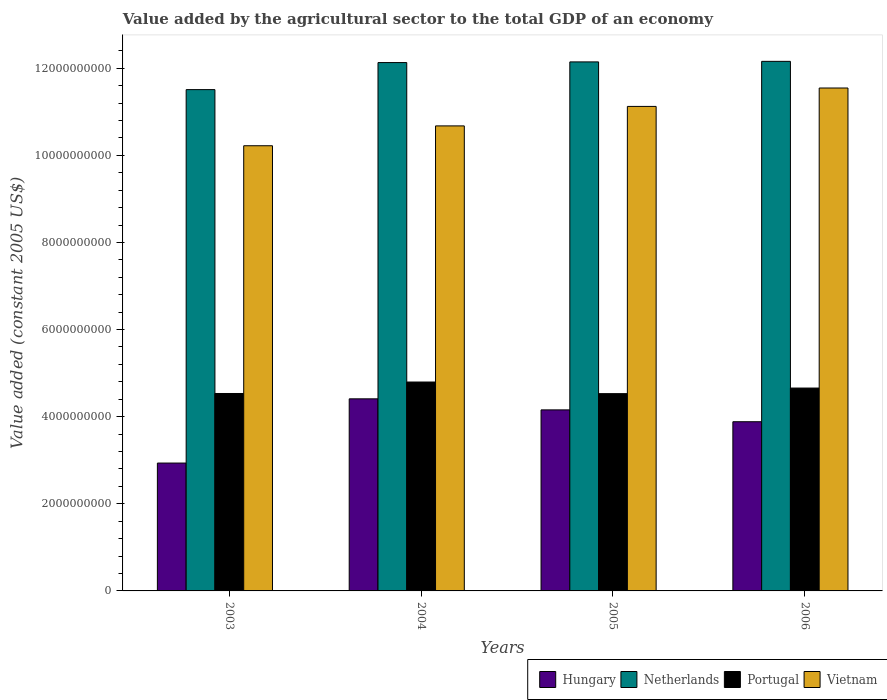Are the number of bars per tick equal to the number of legend labels?
Give a very brief answer. Yes. How many bars are there on the 3rd tick from the left?
Your response must be concise. 4. In how many cases, is the number of bars for a given year not equal to the number of legend labels?
Offer a very short reply. 0. What is the value added by the agricultural sector in Hungary in 2005?
Offer a terse response. 4.16e+09. Across all years, what is the maximum value added by the agricultural sector in Netherlands?
Offer a terse response. 1.22e+1. Across all years, what is the minimum value added by the agricultural sector in Hungary?
Your response must be concise. 2.94e+09. In which year was the value added by the agricultural sector in Hungary minimum?
Provide a short and direct response. 2003. What is the total value added by the agricultural sector in Portugal in the graph?
Keep it short and to the point. 1.85e+1. What is the difference between the value added by the agricultural sector in Vietnam in 2003 and that in 2006?
Give a very brief answer. -1.33e+09. What is the difference between the value added by the agricultural sector in Netherlands in 2003 and the value added by the agricultural sector in Hungary in 2006?
Provide a short and direct response. 7.62e+09. What is the average value added by the agricultural sector in Hungary per year?
Make the answer very short. 3.85e+09. In the year 2003, what is the difference between the value added by the agricultural sector in Portugal and value added by the agricultural sector in Netherlands?
Your response must be concise. -6.98e+09. What is the ratio of the value added by the agricultural sector in Portugal in 2004 to that in 2005?
Provide a succinct answer. 1.06. Is the value added by the agricultural sector in Vietnam in 2003 less than that in 2004?
Offer a very short reply. Yes. What is the difference between the highest and the second highest value added by the agricultural sector in Hungary?
Make the answer very short. 2.54e+08. What is the difference between the highest and the lowest value added by the agricultural sector in Vietnam?
Provide a short and direct response. 1.33e+09. Is the sum of the value added by the agricultural sector in Vietnam in 2003 and 2006 greater than the maximum value added by the agricultural sector in Hungary across all years?
Your answer should be compact. Yes. What does the 1st bar from the right in 2003 represents?
Your answer should be very brief. Vietnam. Is it the case that in every year, the sum of the value added by the agricultural sector in Netherlands and value added by the agricultural sector in Vietnam is greater than the value added by the agricultural sector in Portugal?
Ensure brevity in your answer.  Yes. How many bars are there?
Keep it short and to the point. 16. Are all the bars in the graph horizontal?
Offer a very short reply. No. What is the difference between two consecutive major ticks on the Y-axis?
Your response must be concise. 2.00e+09. Does the graph contain any zero values?
Make the answer very short. No. Where does the legend appear in the graph?
Your response must be concise. Bottom right. How are the legend labels stacked?
Your answer should be compact. Horizontal. What is the title of the graph?
Ensure brevity in your answer.  Value added by the agricultural sector to the total GDP of an economy. Does "Burkina Faso" appear as one of the legend labels in the graph?
Your response must be concise. No. What is the label or title of the Y-axis?
Provide a succinct answer. Value added (constant 2005 US$). What is the Value added (constant 2005 US$) of Hungary in 2003?
Offer a very short reply. 2.94e+09. What is the Value added (constant 2005 US$) in Netherlands in 2003?
Your response must be concise. 1.15e+1. What is the Value added (constant 2005 US$) of Portugal in 2003?
Offer a terse response. 4.53e+09. What is the Value added (constant 2005 US$) of Vietnam in 2003?
Provide a short and direct response. 1.02e+1. What is the Value added (constant 2005 US$) of Hungary in 2004?
Keep it short and to the point. 4.41e+09. What is the Value added (constant 2005 US$) in Netherlands in 2004?
Ensure brevity in your answer.  1.21e+1. What is the Value added (constant 2005 US$) of Portugal in 2004?
Your response must be concise. 4.80e+09. What is the Value added (constant 2005 US$) in Vietnam in 2004?
Make the answer very short. 1.07e+1. What is the Value added (constant 2005 US$) in Hungary in 2005?
Make the answer very short. 4.16e+09. What is the Value added (constant 2005 US$) in Netherlands in 2005?
Offer a very short reply. 1.21e+1. What is the Value added (constant 2005 US$) in Portugal in 2005?
Offer a very short reply. 4.53e+09. What is the Value added (constant 2005 US$) in Vietnam in 2005?
Your answer should be very brief. 1.11e+1. What is the Value added (constant 2005 US$) in Hungary in 2006?
Your response must be concise. 3.88e+09. What is the Value added (constant 2005 US$) in Netherlands in 2006?
Offer a terse response. 1.22e+1. What is the Value added (constant 2005 US$) in Portugal in 2006?
Make the answer very short. 4.66e+09. What is the Value added (constant 2005 US$) of Vietnam in 2006?
Give a very brief answer. 1.15e+1. Across all years, what is the maximum Value added (constant 2005 US$) in Hungary?
Ensure brevity in your answer.  4.41e+09. Across all years, what is the maximum Value added (constant 2005 US$) in Netherlands?
Your answer should be compact. 1.22e+1. Across all years, what is the maximum Value added (constant 2005 US$) in Portugal?
Your answer should be compact. 4.80e+09. Across all years, what is the maximum Value added (constant 2005 US$) in Vietnam?
Offer a very short reply. 1.15e+1. Across all years, what is the minimum Value added (constant 2005 US$) in Hungary?
Offer a very short reply. 2.94e+09. Across all years, what is the minimum Value added (constant 2005 US$) of Netherlands?
Your answer should be very brief. 1.15e+1. Across all years, what is the minimum Value added (constant 2005 US$) of Portugal?
Provide a succinct answer. 4.53e+09. Across all years, what is the minimum Value added (constant 2005 US$) of Vietnam?
Provide a short and direct response. 1.02e+1. What is the total Value added (constant 2005 US$) of Hungary in the graph?
Provide a short and direct response. 1.54e+1. What is the total Value added (constant 2005 US$) of Netherlands in the graph?
Ensure brevity in your answer.  4.79e+1. What is the total Value added (constant 2005 US$) in Portugal in the graph?
Keep it short and to the point. 1.85e+1. What is the total Value added (constant 2005 US$) in Vietnam in the graph?
Your answer should be compact. 4.36e+1. What is the difference between the Value added (constant 2005 US$) of Hungary in 2003 and that in 2004?
Your answer should be very brief. -1.47e+09. What is the difference between the Value added (constant 2005 US$) in Netherlands in 2003 and that in 2004?
Provide a short and direct response. -6.21e+08. What is the difference between the Value added (constant 2005 US$) of Portugal in 2003 and that in 2004?
Make the answer very short. -2.63e+08. What is the difference between the Value added (constant 2005 US$) of Vietnam in 2003 and that in 2004?
Provide a short and direct response. -4.56e+08. What is the difference between the Value added (constant 2005 US$) in Hungary in 2003 and that in 2005?
Your answer should be very brief. -1.22e+09. What is the difference between the Value added (constant 2005 US$) in Netherlands in 2003 and that in 2005?
Keep it short and to the point. -6.36e+08. What is the difference between the Value added (constant 2005 US$) in Portugal in 2003 and that in 2005?
Provide a succinct answer. 3.53e+06. What is the difference between the Value added (constant 2005 US$) of Vietnam in 2003 and that in 2005?
Your response must be concise. -9.03e+08. What is the difference between the Value added (constant 2005 US$) of Hungary in 2003 and that in 2006?
Your answer should be very brief. -9.49e+08. What is the difference between the Value added (constant 2005 US$) of Netherlands in 2003 and that in 2006?
Offer a terse response. -6.49e+08. What is the difference between the Value added (constant 2005 US$) in Portugal in 2003 and that in 2006?
Provide a short and direct response. -1.25e+08. What is the difference between the Value added (constant 2005 US$) of Vietnam in 2003 and that in 2006?
Offer a very short reply. -1.33e+09. What is the difference between the Value added (constant 2005 US$) of Hungary in 2004 and that in 2005?
Your response must be concise. 2.54e+08. What is the difference between the Value added (constant 2005 US$) of Netherlands in 2004 and that in 2005?
Your response must be concise. -1.54e+07. What is the difference between the Value added (constant 2005 US$) of Portugal in 2004 and that in 2005?
Offer a very short reply. 2.67e+08. What is the difference between the Value added (constant 2005 US$) in Vietnam in 2004 and that in 2005?
Offer a terse response. -4.47e+08. What is the difference between the Value added (constant 2005 US$) of Hungary in 2004 and that in 2006?
Your response must be concise. 5.26e+08. What is the difference between the Value added (constant 2005 US$) in Netherlands in 2004 and that in 2006?
Keep it short and to the point. -2.79e+07. What is the difference between the Value added (constant 2005 US$) in Portugal in 2004 and that in 2006?
Make the answer very short. 1.38e+08. What is the difference between the Value added (constant 2005 US$) of Vietnam in 2004 and that in 2006?
Offer a terse response. -8.70e+08. What is the difference between the Value added (constant 2005 US$) of Hungary in 2005 and that in 2006?
Ensure brevity in your answer.  2.72e+08. What is the difference between the Value added (constant 2005 US$) of Netherlands in 2005 and that in 2006?
Offer a very short reply. -1.24e+07. What is the difference between the Value added (constant 2005 US$) of Portugal in 2005 and that in 2006?
Ensure brevity in your answer.  -1.28e+08. What is the difference between the Value added (constant 2005 US$) in Vietnam in 2005 and that in 2006?
Give a very brief answer. -4.22e+08. What is the difference between the Value added (constant 2005 US$) in Hungary in 2003 and the Value added (constant 2005 US$) in Netherlands in 2004?
Make the answer very short. -9.19e+09. What is the difference between the Value added (constant 2005 US$) of Hungary in 2003 and the Value added (constant 2005 US$) of Portugal in 2004?
Your answer should be compact. -1.86e+09. What is the difference between the Value added (constant 2005 US$) of Hungary in 2003 and the Value added (constant 2005 US$) of Vietnam in 2004?
Your response must be concise. -7.74e+09. What is the difference between the Value added (constant 2005 US$) of Netherlands in 2003 and the Value added (constant 2005 US$) of Portugal in 2004?
Offer a terse response. 6.71e+09. What is the difference between the Value added (constant 2005 US$) in Netherlands in 2003 and the Value added (constant 2005 US$) in Vietnam in 2004?
Keep it short and to the point. 8.33e+08. What is the difference between the Value added (constant 2005 US$) in Portugal in 2003 and the Value added (constant 2005 US$) in Vietnam in 2004?
Offer a very short reply. -6.14e+09. What is the difference between the Value added (constant 2005 US$) in Hungary in 2003 and the Value added (constant 2005 US$) in Netherlands in 2005?
Offer a very short reply. -9.21e+09. What is the difference between the Value added (constant 2005 US$) of Hungary in 2003 and the Value added (constant 2005 US$) of Portugal in 2005?
Offer a very short reply. -1.59e+09. What is the difference between the Value added (constant 2005 US$) in Hungary in 2003 and the Value added (constant 2005 US$) in Vietnam in 2005?
Your answer should be compact. -8.19e+09. What is the difference between the Value added (constant 2005 US$) of Netherlands in 2003 and the Value added (constant 2005 US$) of Portugal in 2005?
Ensure brevity in your answer.  6.98e+09. What is the difference between the Value added (constant 2005 US$) of Netherlands in 2003 and the Value added (constant 2005 US$) of Vietnam in 2005?
Offer a very short reply. 3.86e+08. What is the difference between the Value added (constant 2005 US$) of Portugal in 2003 and the Value added (constant 2005 US$) of Vietnam in 2005?
Ensure brevity in your answer.  -6.59e+09. What is the difference between the Value added (constant 2005 US$) in Hungary in 2003 and the Value added (constant 2005 US$) in Netherlands in 2006?
Your answer should be compact. -9.22e+09. What is the difference between the Value added (constant 2005 US$) of Hungary in 2003 and the Value added (constant 2005 US$) of Portugal in 2006?
Offer a very short reply. -1.72e+09. What is the difference between the Value added (constant 2005 US$) in Hungary in 2003 and the Value added (constant 2005 US$) in Vietnam in 2006?
Your response must be concise. -8.61e+09. What is the difference between the Value added (constant 2005 US$) in Netherlands in 2003 and the Value added (constant 2005 US$) in Portugal in 2006?
Provide a succinct answer. 6.85e+09. What is the difference between the Value added (constant 2005 US$) in Netherlands in 2003 and the Value added (constant 2005 US$) in Vietnam in 2006?
Ensure brevity in your answer.  -3.67e+07. What is the difference between the Value added (constant 2005 US$) in Portugal in 2003 and the Value added (constant 2005 US$) in Vietnam in 2006?
Ensure brevity in your answer.  -7.01e+09. What is the difference between the Value added (constant 2005 US$) in Hungary in 2004 and the Value added (constant 2005 US$) in Netherlands in 2005?
Give a very brief answer. -7.74e+09. What is the difference between the Value added (constant 2005 US$) of Hungary in 2004 and the Value added (constant 2005 US$) of Portugal in 2005?
Keep it short and to the point. -1.19e+08. What is the difference between the Value added (constant 2005 US$) in Hungary in 2004 and the Value added (constant 2005 US$) in Vietnam in 2005?
Your answer should be very brief. -6.71e+09. What is the difference between the Value added (constant 2005 US$) of Netherlands in 2004 and the Value added (constant 2005 US$) of Portugal in 2005?
Provide a succinct answer. 7.60e+09. What is the difference between the Value added (constant 2005 US$) of Netherlands in 2004 and the Value added (constant 2005 US$) of Vietnam in 2005?
Your response must be concise. 1.01e+09. What is the difference between the Value added (constant 2005 US$) of Portugal in 2004 and the Value added (constant 2005 US$) of Vietnam in 2005?
Offer a very short reply. -6.33e+09. What is the difference between the Value added (constant 2005 US$) of Hungary in 2004 and the Value added (constant 2005 US$) of Netherlands in 2006?
Provide a succinct answer. -7.75e+09. What is the difference between the Value added (constant 2005 US$) of Hungary in 2004 and the Value added (constant 2005 US$) of Portugal in 2006?
Your response must be concise. -2.47e+08. What is the difference between the Value added (constant 2005 US$) of Hungary in 2004 and the Value added (constant 2005 US$) of Vietnam in 2006?
Make the answer very short. -7.14e+09. What is the difference between the Value added (constant 2005 US$) in Netherlands in 2004 and the Value added (constant 2005 US$) in Portugal in 2006?
Your response must be concise. 7.47e+09. What is the difference between the Value added (constant 2005 US$) in Netherlands in 2004 and the Value added (constant 2005 US$) in Vietnam in 2006?
Ensure brevity in your answer.  5.84e+08. What is the difference between the Value added (constant 2005 US$) of Portugal in 2004 and the Value added (constant 2005 US$) of Vietnam in 2006?
Ensure brevity in your answer.  -6.75e+09. What is the difference between the Value added (constant 2005 US$) in Hungary in 2005 and the Value added (constant 2005 US$) in Netherlands in 2006?
Provide a succinct answer. -8.00e+09. What is the difference between the Value added (constant 2005 US$) of Hungary in 2005 and the Value added (constant 2005 US$) of Portugal in 2006?
Give a very brief answer. -5.01e+08. What is the difference between the Value added (constant 2005 US$) in Hungary in 2005 and the Value added (constant 2005 US$) in Vietnam in 2006?
Your response must be concise. -7.39e+09. What is the difference between the Value added (constant 2005 US$) of Netherlands in 2005 and the Value added (constant 2005 US$) of Portugal in 2006?
Provide a short and direct response. 7.49e+09. What is the difference between the Value added (constant 2005 US$) in Netherlands in 2005 and the Value added (constant 2005 US$) in Vietnam in 2006?
Keep it short and to the point. 6.00e+08. What is the difference between the Value added (constant 2005 US$) in Portugal in 2005 and the Value added (constant 2005 US$) in Vietnam in 2006?
Keep it short and to the point. -7.02e+09. What is the average Value added (constant 2005 US$) of Hungary per year?
Your answer should be very brief. 3.85e+09. What is the average Value added (constant 2005 US$) of Netherlands per year?
Offer a very short reply. 1.20e+1. What is the average Value added (constant 2005 US$) of Portugal per year?
Keep it short and to the point. 4.63e+09. What is the average Value added (constant 2005 US$) of Vietnam per year?
Provide a succinct answer. 1.09e+1. In the year 2003, what is the difference between the Value added (constant 2005 US$) of Hungary and Value added (constant 2005 US$) of Netherlands?
Make the answer very short. -8.57e+09. In the year 2003, what is the difference between the Value added (constant 2005 US$) in Hungary and Value added (constant 2005 US$) in Portugal?
Provide a succinct answer. -1.60e+09. In the year 2003, what is the difference between the Value added (constant 2005 US$) in Hungary and Value added (constant 2005 US$) in Vietnam?
Offer a terse response. -7.28e+09. In the year 2003, what is the difference between the Value added (constant 2005 US$) of Netherlands and Value added (constant 2005 US$) of Portugal?
Keep it short and to the point. 6.98e+09. In the year 2003, what is the difference between the Value added (constant 2005 US$) in Netherlands and Value added (constant 2005 US$) in Vietnam?
Provide a succinct answer. 1.29e+09. In the year 2003, what is the difference between the Value added (constant 2005 US$) of Portugal and Value added (constant 2005 US$) of Vietnam?
Provide a succinct answer. -5.69e+09. In the year 2004, what is the difference between the Value added (constant 2005 US$) in Hungary and Value added (constant 2005 US$) in Netherlands?
Provide a short and direct response. -7.72e+09. In the year 2004, what is the difference between the Value added (constant 2005 US$) in Hungary and Value added (constant 2005 US$) in Portugal?
Offer a terse response. -3.86e+08. In the year 2004, what is the difference between the Value added (constant 2005 US$) in Hungary and Value added (constant 2005 US$) in Vietnam?
Give a very brief answer. -6.27e+09. In the year 2004, what is the difference between the Value added (constant 2005 US$) in Netherlands and Value added (constant 2005 US$) in Portugal?
Ensure brevity in your answer.  7.33e+09. In the year 2004, what is the difference between the Value added (constant 2005 US$) of Netherlands and Value added (constant 2005 US$) of Vietnam?
Ensure brevity in your answer.  1.45e+09. In the year 2004, what is the difference between the Value added (constant 2005 US$) of Portugal and Value added (constant 2005 US$) of Vietnam?
Keep it short and to the point. -5.88e+09. In the year 2005, what is the difference between the Value added (constant 2005 US$) in Hungary and Value added (constant 2005 US$) in Netherlands?
Make the answer very short. -7.99e+09. In the year 2005, what is the difference between the Value added (constant 2005 US$) in Hungary and Value added (constant 2005 US$) in Portugal?
Your response must be concise. -3.73e+08. In the year 2005, what is the difference between the Value added (constant 2005 US$) of Hungary and Value added (constant 2005 US$) of Vietnam?
Your answer should be compact. -6.97e+09. In the year 2005, what is the difference between the Value added (constant 2005 US$) of Netherlands and Value added (constant 2005 US$) of Portugal?
Your answer should be very brief. 7.62e+09. In the year 2005, what is the difference between the Value added (constant 2005 US$) of Netherlands and Value added (constant 2005 US$) of Vietnam?
Keep it short and to the point. 1.02e+09. In the year 2005, what is the difference between the Value added (constant 2005 US$) of Portugal and Value added (constant 2005 US$) of Vietnam?
Your answer should be very brief. -6.59e+09. In the year 2006, what is the difference between the Value added (constant 2005 US$) of Hungary and Value added (constant 2005 US$) of Netherlands?
Your answer should be compact. -8.27e+09. In the year 2006, what is the difference between the Value added (constant 2005 US$) in Hungary and Value added (constant 2005 US$) in Portugal?
Provide a succinct answer. -7.73e+08. In the year 2006, what is the difference between the Value added (constant 2005 US$) of Hungary and Value added (constant 2005 US$) of Vietnam?
Ensure brevity in your answer.  -7.66e+09. In the year 2006, what is the difference between the Value added (constant 2005 US$) in Netherlands and Value added (constant 2005 US$) in Portugal?
Provide a short and direct response. 7.50e+09. In the year 2006, what is the difference between the Value added (constant 2005 US$) of Netherlands and Value added (constant 2005 US$) of Vietnam?
Offer a very short reply. 6.12e+08. In the year 2006, what is the difference between the Value added (constant 2005 US$) of Portugal and Value added (constant 2005 US$) of Vietnam?
Ensure brevity in your answer.  -6.89e+09. What is the ratio of the Value added (constant 2005 US$) of Hungary in 2003 to that in 2004?
Your answer should be very brief. 0.67. What is the ratio of the Value added (constant 2005 US$) in Netherlands in 2003 to that in 2004?
Ensure brevity in your answer.  0.95. What is the ratio of the Value added (constant 2005 US$) of Portugal in 2003 to that in 2004?
Your answer should be compact. 0.95. What is the ratio of the Value added (constant 2005 US$) in Vietnam in 2003 to that in 2004?
Offer a terse response. 0.96. What is the ratio of the Value added (constant 2005 US$) in Hungary in 2003 to that in 2005?
Your response must be concise. 0.71. What is the ratio of the Value added (constant 2005 US$) in Netherlands in 2003 to that in 2005?
Keep it short and to the point. 0.95. What is the ratio of the Value added (constant 2005 US$) of Portugal in 2003 to that in 2005?
Provide a short and direct response. 1. What is the ratio of the Value added (constant 2005 US$) in Vietnam in 2003 to that in 2005?
Keep it short and to the point. 0.92. What is the ratio of the Value added (constant 2005 US$) of Hungary in 2003 to that in 2006?
Make the answer very short. 0.76. What is the ratio of the Value added (constant 2005 US$) in Netherlands in 2003 to that in 2006?
Offer a very short reply. 0.95. What is the ratio of the Value added (constant 2005 US$) in Portugal in 2003 to that in 2006?
Your response must be concise. 0.97. What is the ratio of the Value added (constant 2005 US$) of Vietnam in 2003 to that in 2006?
Your response must be concise. 0.89. What is the ratio of the Value added (constant 2005 US$) in Hungary in 2004 to that in 2005?
Keep it short and to the point. 1.06. What is the ratio of the Value added (constant 2005 US$) of Netherlands in 2004 to that in 2005?
Make the answer very short. 1. What is the ratio of the Value added (constant 2005 US$) in Portugal in 2004 to that in 2005?
Your response must be concise. 1.06. What is the ratio of the Value added (constant 2005 US$) of Vietnam in 2004 to that in 2005?
Provide a short and direct response. 0.96. What is the ratio of the Value added (constant 2005 US$) of Hungary in 2004 to that in 2006?
Provide a succinct answer. 1.14. What is the ratio of the Value added (constant 2005 US$) of Portugal in 2004 to that in 2006?
Your answer should be compact. 1.03. What is the ratio of the Value added (constant 2005 US$) in Vietnam in 2004 to that in 2006?
Your answer should be very brief. 0.92. What is the ratio of the Value added (constant 2005 US$) in Hungary in 2005 to that in 2006?
Offer a terse response. 1.07. What is the ratio of the Value added (constant 2005 US$) of Portugal in 2005 to that in 2006?
Your answer should be very brief. 0.97. What is the ratio of the Value added (constant 2005 US$) of Vietnam in 2005 to that in 2006?
Your response must be concise. 0.96. What is the difference between the highest and the second highest Value added (constant 2005 US$) of Hungary?
Provide a succinct answer. 2.54e+08. What is the difference between the highest and the second highest Value added (constant 2005 US$) in Netherlands?
Give a very brief answer. 1.24e+07. What is the difference between the highest and the second highest Value added (constant 2005 US$) in Portugal?
Ensure brevity in your answer.  1.38e+08. What is the difference between the highest and the second highest Value added (constant 2005 US$) of Vietnam?
Your answer should be very brief. 4.22e+08. What is the difference between the highest and the lowest Value added (constant 2005 US$) of Hungary?
Provide a succinct answer. 1.47e+09. What is the difference between the highest and the lowest Value added (constant 2005 US$) of Netherlands?
Provide a succinct answer. 6.49e+08. What is the difference between the highest and the lowest Value added (constant 2005 US$) of Portugal?
Provide a short and direct response. 2.67e+08. What is the difference between the highest and the lowest Value added (constant 2005 US$) in Vietnam?
Your response must be concise. 1.33e+09. 